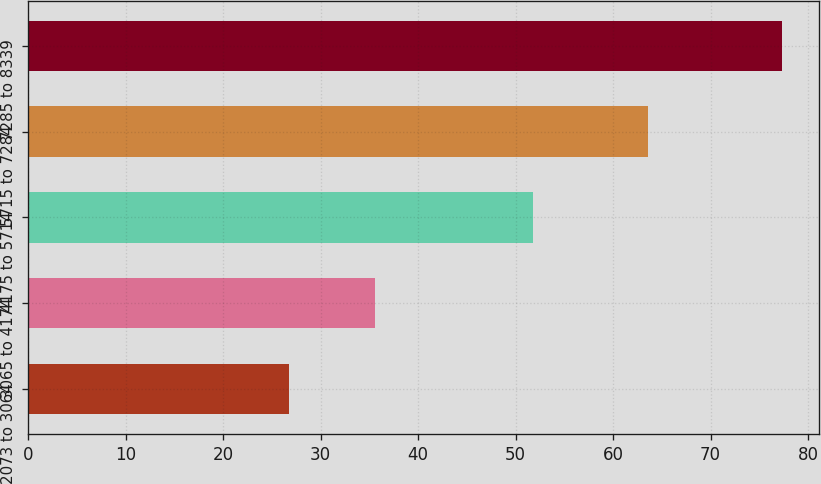Convert chart. <chart><loc_0><loc_0><loc_500><loc_500><bar_chart><fcel>2073 to 3064<fcel>3065 to 4174<fcel>4175 to 5714<fcel>5715 to 7284<fcel>7285 to 8339<nl><fcel>26.73<fcel>35.6<fcel>51.75<fcel>63.54<fcel>77.3<nl></chart> 